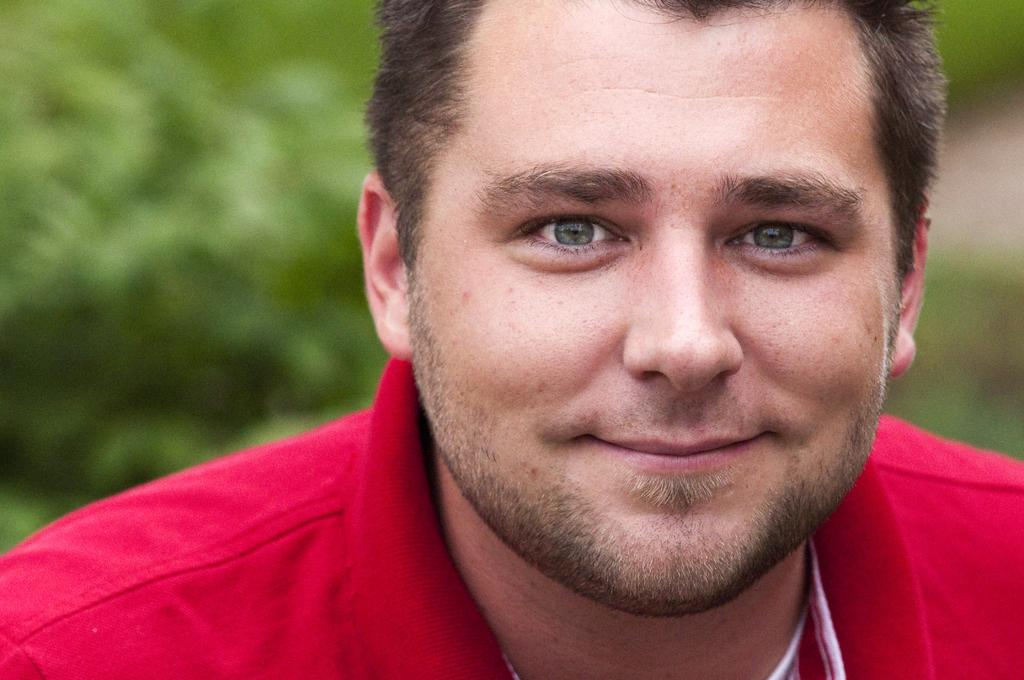What is the main subject of the image? There is a person in the middle of the image. What can be seen in the background of the image? There is greenery in the background of the image. What type of suit is the person wearing in the image? There is no suit visible in the image; the person's clothing is not described. What is the weather like in the image, considering the presence of the sun? There is no sun present in the image, so it cannot be determined if the sun is visible or not. 